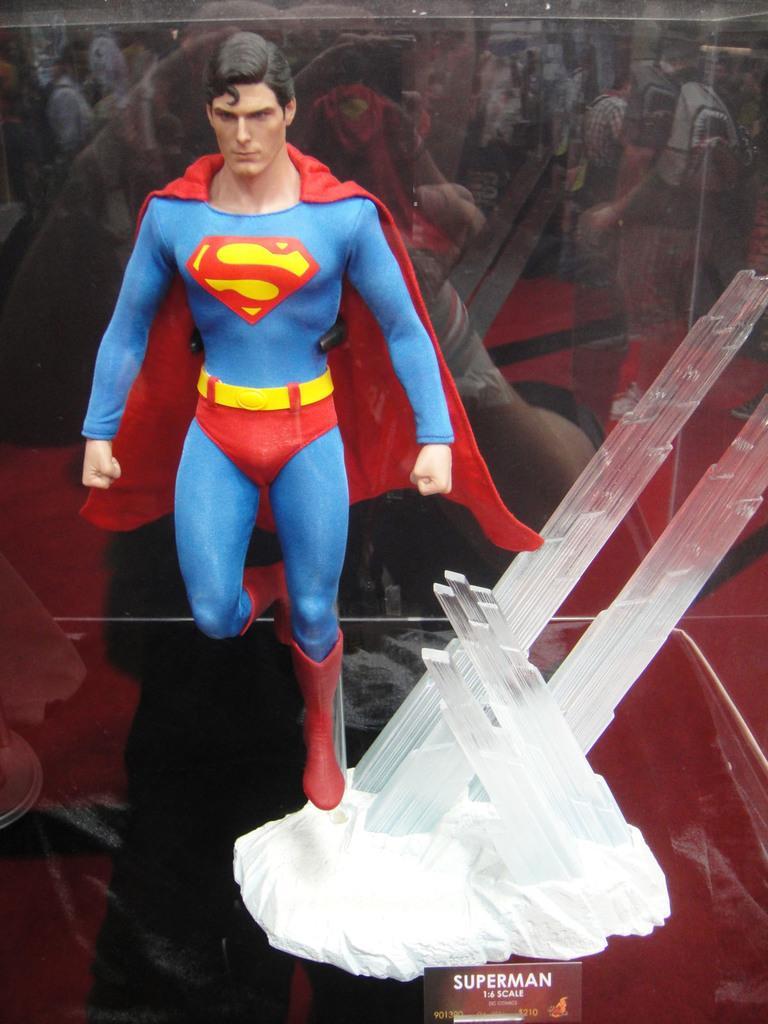In one or two sentences, can you explain what this image depicts? In this picture I can see a toy, there is a board and an object in a glass box, and there is a reflection of group of people. 